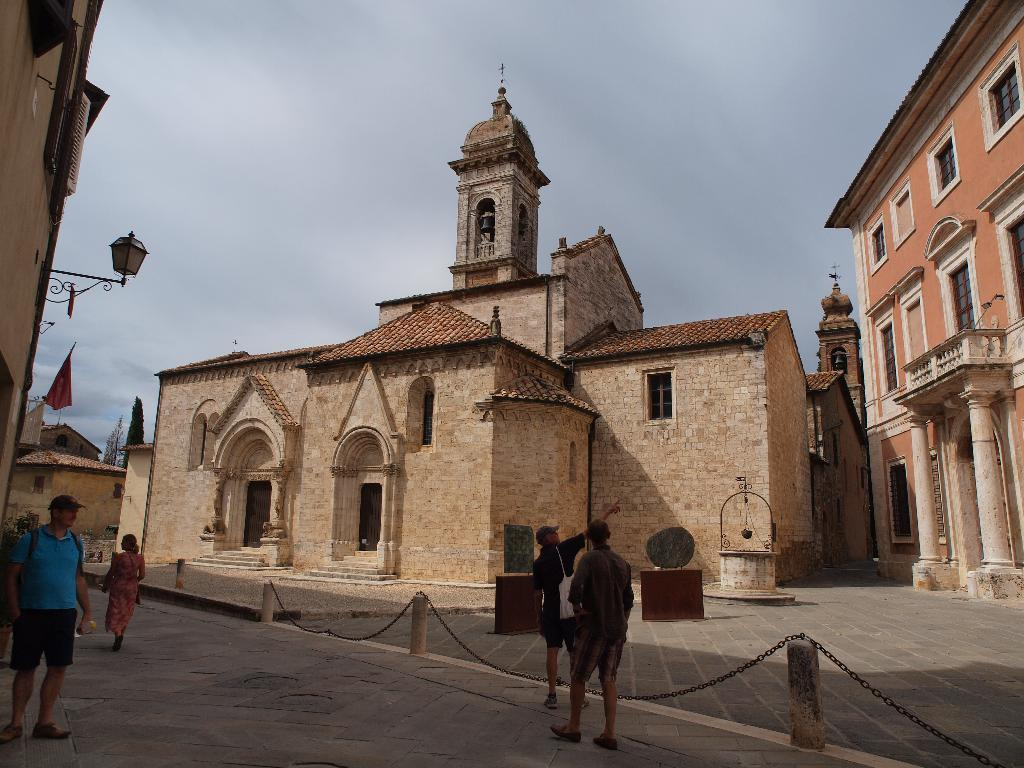What are the people in the image doing? The people in the image are walking on the land in the bottom of the picture. What structure can be seen in the picture? There is a monument in the picture. What part of the natural environment is visible in the image? The sky is visible in the background of the picture. What type of grain is being harvested by the owner in the picture? There is no grain or owner present in the image; it features people walking on the land and a monument. What kind of lamp is illuminating the monument in the picture? There is no lamp present in the image; the monument is visible in daylight, as indicated by the visible sky. 